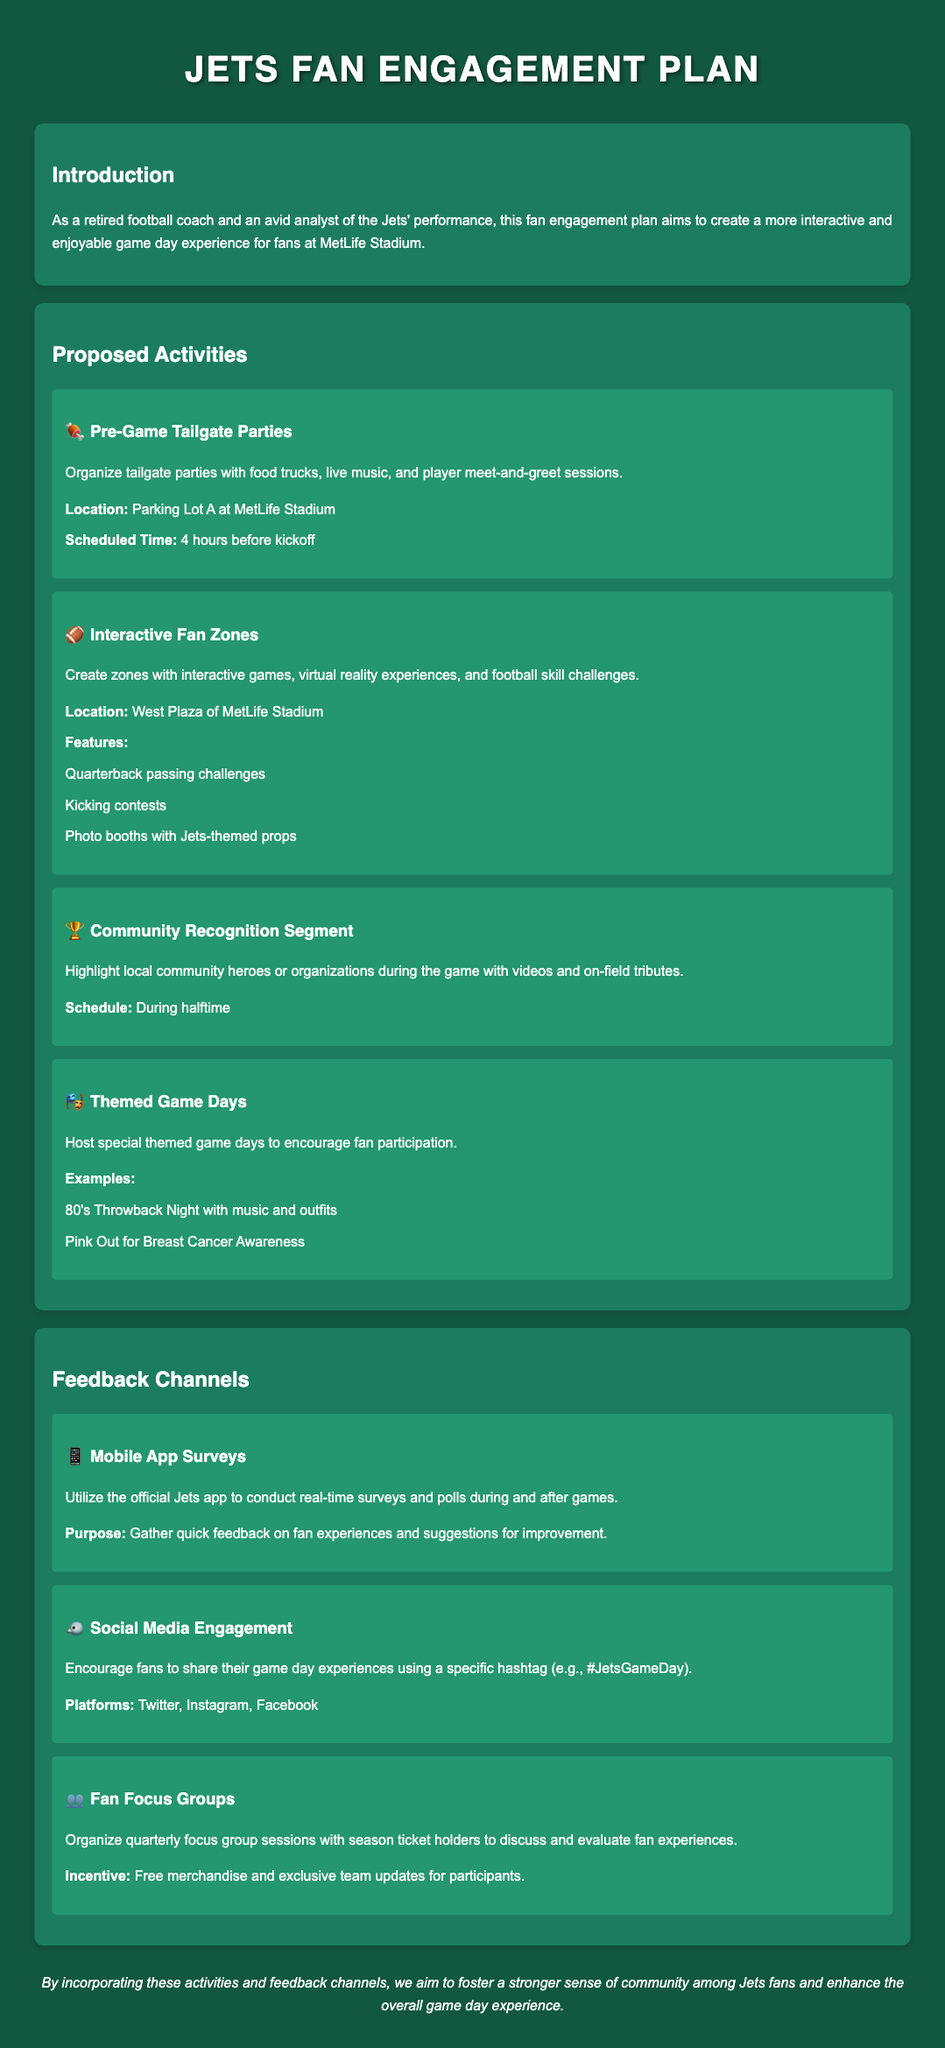What is the location for Pre-Game Tailgate Parties? The location for Pre-Game Tailgate Parties is Parking Lot A at MetLife Stadium.
Answer: Parking Lot A What time are the Pre-Game Tailgate Parties scheduled? The scheduled time for Pre-Game Tailgate Parties is 4 hours before kickoff.
Answer: 4 hours before kickoff What interactive experience will be available in the Fan Zones? The interactive experiences include quarterback passing challenges, kicking contests, and photo booths with Jets-themed props.
Answer: Quarterback passing challenges During which segment will community heroes be recognized? Community heroes will be highlighted during halftime of the game.
Answer: Halftime What is one of the examples of Themed Game Days? One example of Themed Game Days is 80's Throwback Night with music and outfits.
Answer: 80's Throwback Night What is the purpose of Mobile App Surveys? The purpose of Mobile App Surveys is to gather quick feedback on fan experiences and suggestions for improvement.
Answer: Gather quick feedback Which platform will be used for social media engagement? The platforms for social media engagement include Twitter, Instagram, and Facebook.
Answer: Twitter, Instagram, Facebook What incentive is offered to participants of the focus group? The incentive offered to participants of the focus group is free merchandise and exclusive team updates.
Answer: Free merchandise and exclusive team updates 